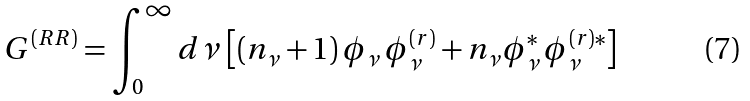Convert formula to latex. <formula><loc_0><loc_0><loc_500><loc_500>G ^ { ( R R ) } = \int _ { 0 } ^ { \infty } d \nu \, \left [ ( n _ { \nu } + 1 ) \, \phi _ { \nu } \, \phi _ { \nu } ^ { ( r ) } + n _ { \nu } \phi _ { \nu } ^ { * } \, \phi _ { \nu } ^ { ( r ) * } \right ]</formula> 